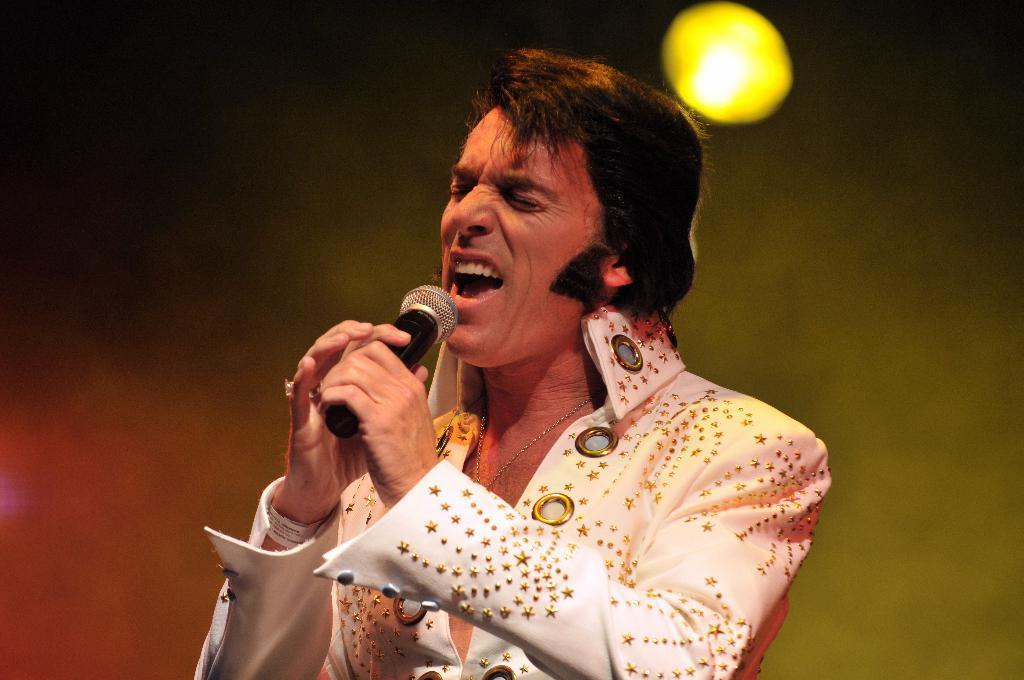How would you summarize this image in a sentence or two? In the image we can see a man wearing clothes, neck chain and the man is singing. He is holding a microphone in his hand, here we can see a light, yellow and white in color, and the background is dark. 